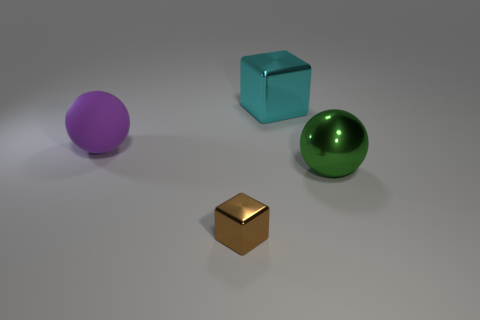Add 1 big brown rubber cylinders. How many objects exist? 5 Subtract all big gray shiny things. Subtract all purple rubber balls. How many objects are left? 3 Add 4 tiny brown blocks. How many tiny brown blocks are left? 5 Add 4 green metallic objects. How many green metallic objects exist? 5 Subtract 0 gray balls. How many objects are left? 4 